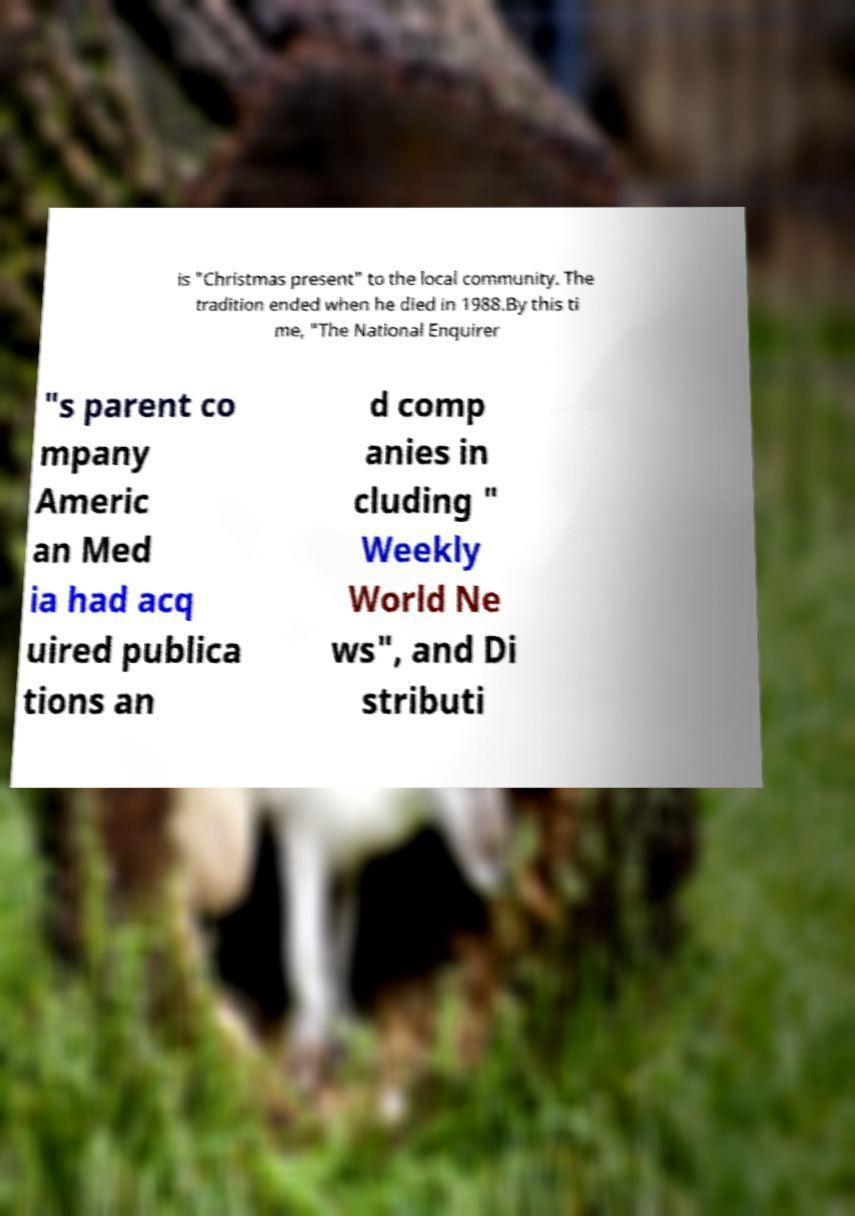Could you assist in decoding the text presented in this image and type it out clearly? is "Christmas present" to the local community. The tradition ended when he died in 1988.By this ti me, "The National Enquirer "s parent co mpany Americ an Med ia had acq uired publica tions an d comp anies in cluding " Weekly World Ne ws", and Di stributi 